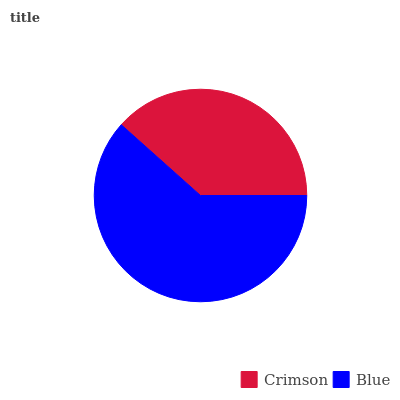Is Crimson the minimum?
Answer yes or no. Yes. Is Blue the maximum?
Answer yes or no. Yes. Is Blue the minimum?
Answer yes or no. No. Is Blue greater than Crimson?
Answer yes or no. Yes. Is Crimson less than Blue?
Answer yes or no. Yes. Is Crimson greater than Blue?
Answer yes or no. No. Is Blue less than Crimson?
Answer yes or no. No. Is Blue the high median?
Answer yes or no. Yes. Is Crimson the low median?
Answer yes or no. Yes. Is Crimson the high median?
Answer yes or no. No. Is Blue the low median?
Answer yes or no. No. 